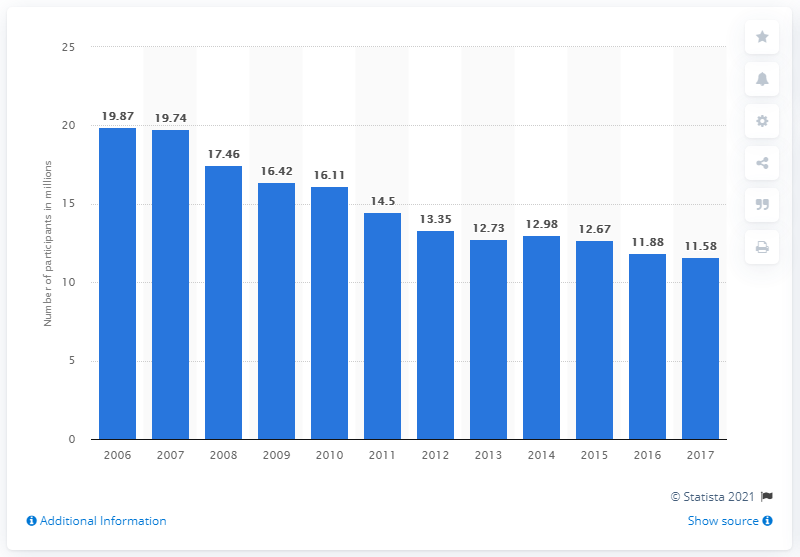Specify some key components in this picture. In 2017, 11.88 U.S. citizens participated in roller skating. 